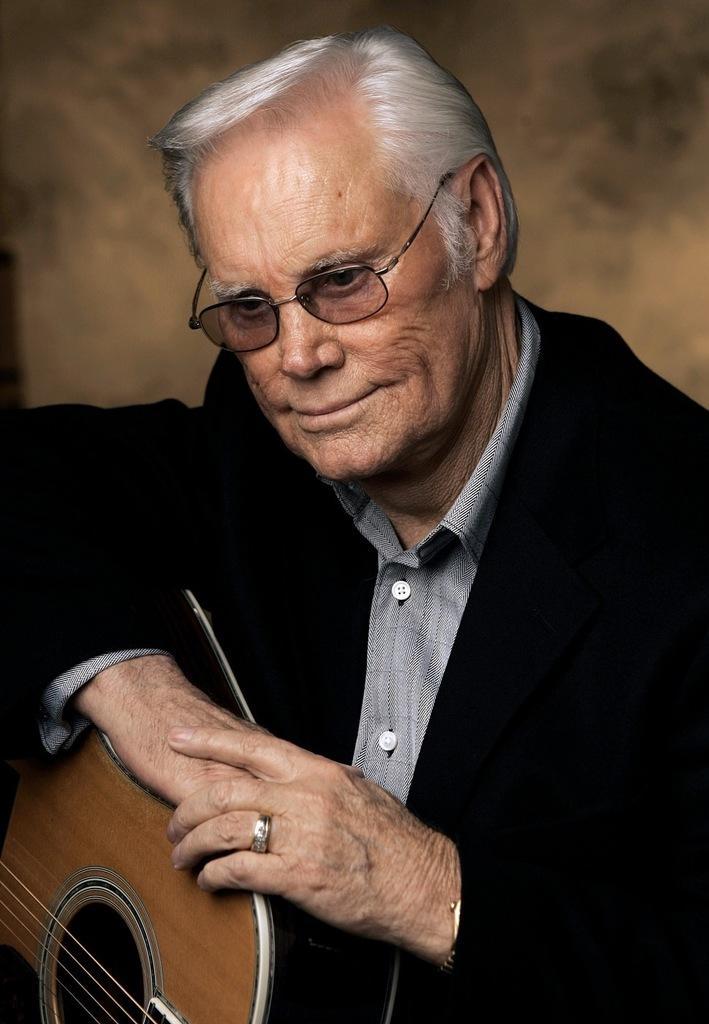Describe this image in one or two sentences. In this image we have a man sitting and holding a guitar in his hand. 